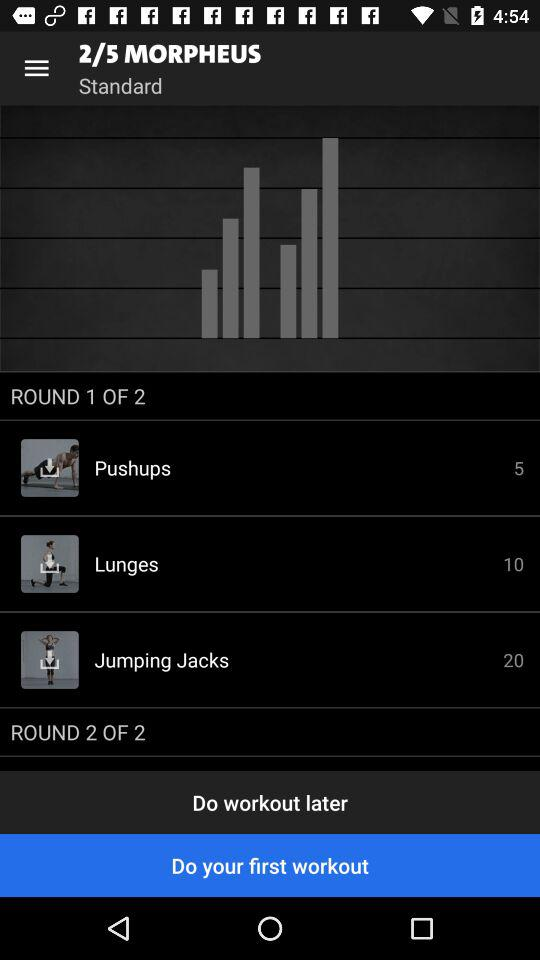How many rounds of exercises are there?
Answer the question using a single word or phrase. 2 